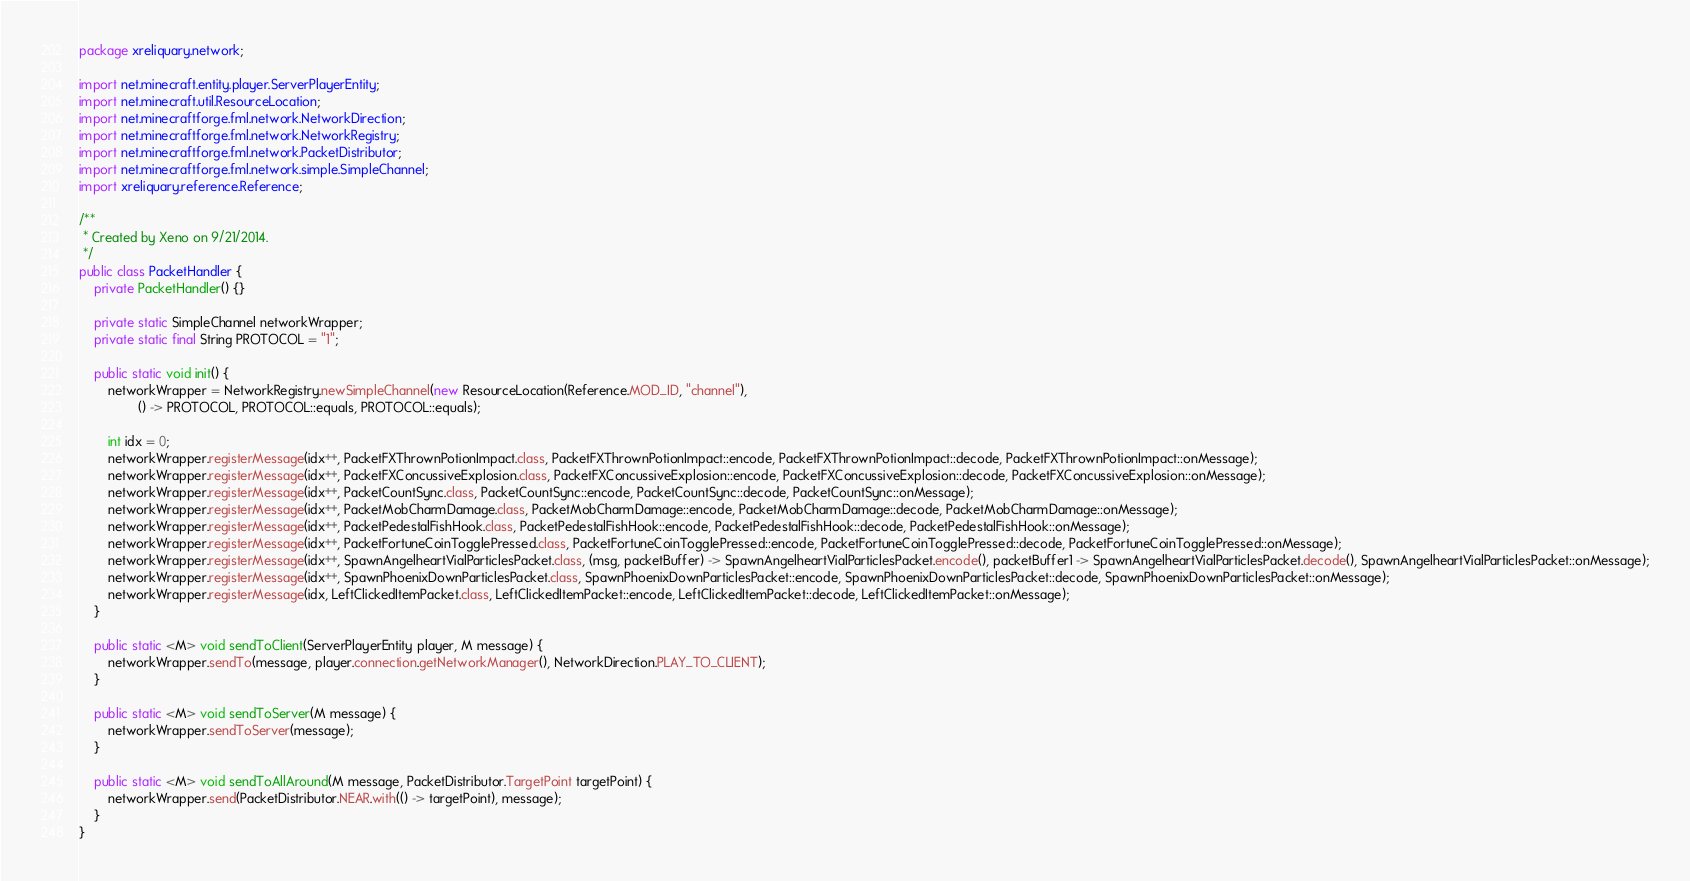Convert code to text. <code><loc_0><loc_0><loc_500><loc_500><_Java_>package xreliquary.network;

import net.minecraft.entity.player.ServerPlayerEntity;
import net.minecraft.util.ResourceLocation;
import net.minecraftforge.fml.network.NetworkDirection;
import net.minecraftforge.fml.network.NetworkRegistry;
import net.minecraftforge.fml.network.PacketDistributor;
import net.minecraftforge.fml.network.simple.SimpleChannel;
import xreliquary.reference.Reference;

/**
 * Created by Xeno on 9/21/2014.
 */
public class PacketHandler {
	private PacketHandler() {}

	private static SimpleChannel networkWrapper;
	private static final String PROTOCOL = "1";

	public static void init() {
		networkWrapper = NetworkRegistry.newSimpleChannel(new ResourceLocation(Reference.MOD_ID, "channel"),
				() -> PROTOCOL, PROTOCOL::equals, PROTOCOL::equals);

		int idx = 0;
		networkWrapper.registerMessage(idx++, PacketFXThrownPotionImpact.class, PacketFXThrownPotionImpact::encode, PacketFXThrownPotionImpact::decode, PacketFXThrownPotionImpact::onMessage);
		networkWrapper.registerMessage(idx++, PacketFXConcussiveExplosion.class, PacketFXConcussiveExplosion::encode, PacketFXConcussiveExplosion::decode, PacketFXConcussiveExplosion::onMessage);
		networkWrapper.registerMessage(idx++, PacketCountSync.class, PacketCountSync::encode, PacketCountSync::decode, PacketCountSync::onMessage);
		networkWrapper.registerMessage(idx++, PacketMobCharmDamage.class, PacketMobCharmDamage::encode, PacketMobCharmDamage::decode, PacketMobCharmDamage::onMessage);
		networkWrapper.registerMessage(idx++, PacketPedestalFishHook.class, PacketPedestalFishHook::encode, PacketPedestalFishHook::decode, PacketPedestalFishHook::onMessage);
		networkWrapper.registerMessage(idx++, PacketFortuneCoinTogglePressed.class, PacketFortuneCoinTogglePressed::encode, PacketFortuneCoinTogglePressed::decode, PacketFortuneCoinTogglePressed::onMessage);
		networkWrapper.registerMessage(idx++, SpawnAngelheartVialParticlesPacket.class, (msg, packetBuffer) -> SpawnAngelheartVialParticlesPacket.encode(), packetBuffer1 -> SpawnAngelheartVialParticlesPacket.decode(), SpawnAngelheartVialParticlesPacket::onMessage);
		networkWrapper.registerMessage(idx++, SpawnPhoenixDownParticlesPacket.class, SpawnPhoenixDownParticlesPacket::encode, SpawnPhoenixDownParticlesPacket::decode, SpawnPhoenixDownParticlesPacket::onMessage);
		networkWrapper.registerMessage(idx, LeftClickedItemPacket.class, LeftClickedItemPacket::encode, LeftClickedItemPacket::decode, LeftClickedItemPacket::onMessage);
	}

	public static <M> void sendToClient(ServerPlayerEntity player, M message) {
		networkWrapper.sendTo(message, player.connection.getNetworkManager(), NetworkDirection.PLAY_TO_CLIENT);
	}

	public static <M> void sendToServer(M message) {
		networkWrapper.sendToServer(message);
	}

	public static <M> void sendToAllAround(M message, PacketDistributor.TargetPoint targetPoint) {
		networkWrapper.send(PacketDistributor.NEAR.with(() -> targetPoint), message);
	}
}
</code> 